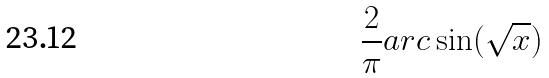<formula> <loc_0><loc_0><loc_500><loc_500>\frac { 2 } { \pi } a r c \sin ( \sqrt { x } )</formula> 